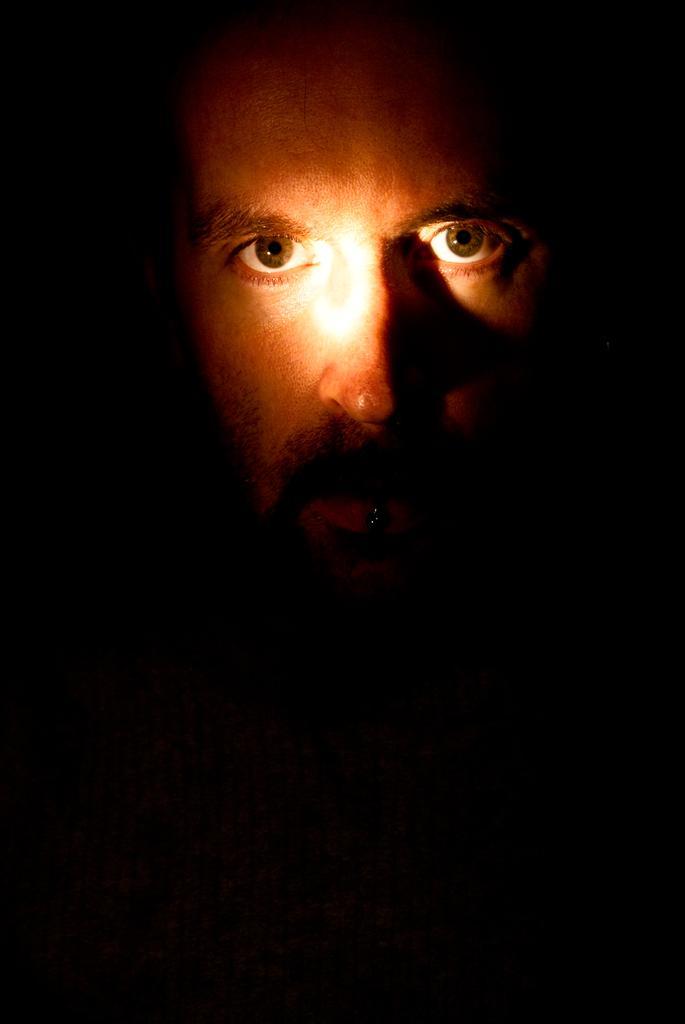Describe this image in one or two sentences. In this image we can see a person's face and the background is dark in color. 